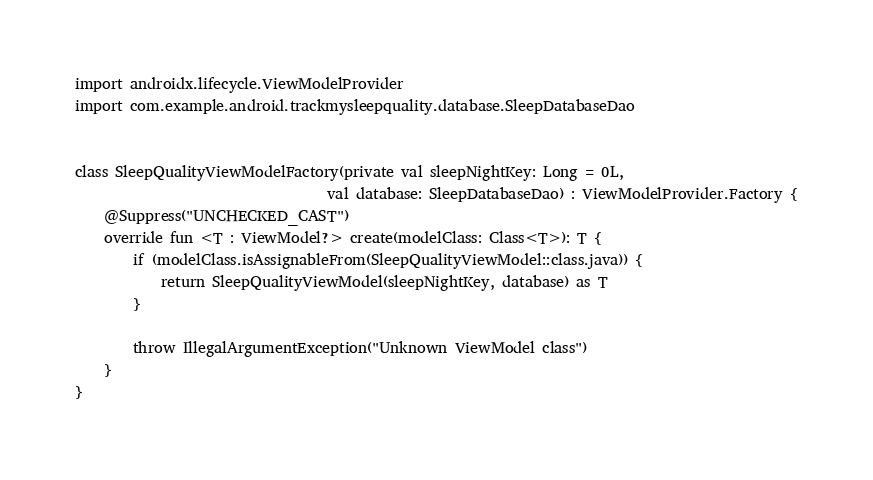<code> <loc_0><loc_0><loc_500><loc_500><_Kotlin_>import androidx.lifecycle.ViewModelProvider
import com.example.android.trackmysleepquality.database.SleepDatabaseDao


class SleepQualityViewModelFactory(private val sleepNightKey: Long = 0L,
                                   val database: SleepDatabaseDao) : ViewModelProvider.Factory {
    @Suppress("UNCHECKED_CAST")
    override fun <T : ViewModel?> create(modelClass: Class<T>): T {
        if (modelClass.isAssignableFrom(SleepQualityViewModel::class.java)) {
            return SleepQualityViewModel(sleepNightKey, database) as T
        }

        throw IllegalArgumentException("Unknown ViewModel class")
    }
}</code> 